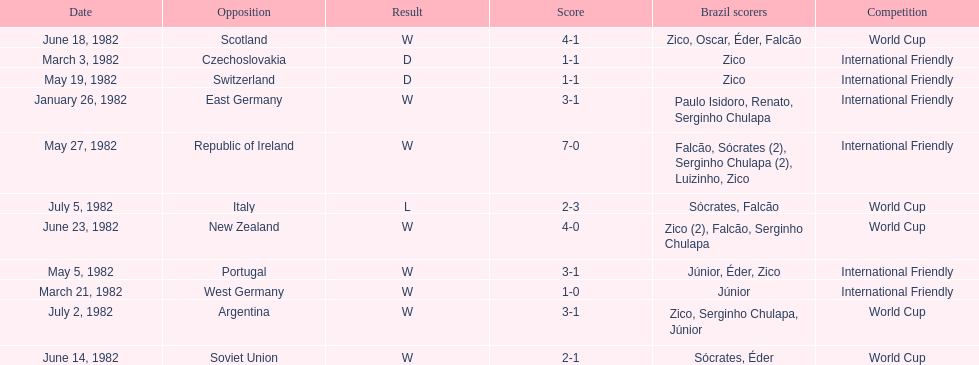What is the number of games won by brazil during the month of march 1982? 1. 